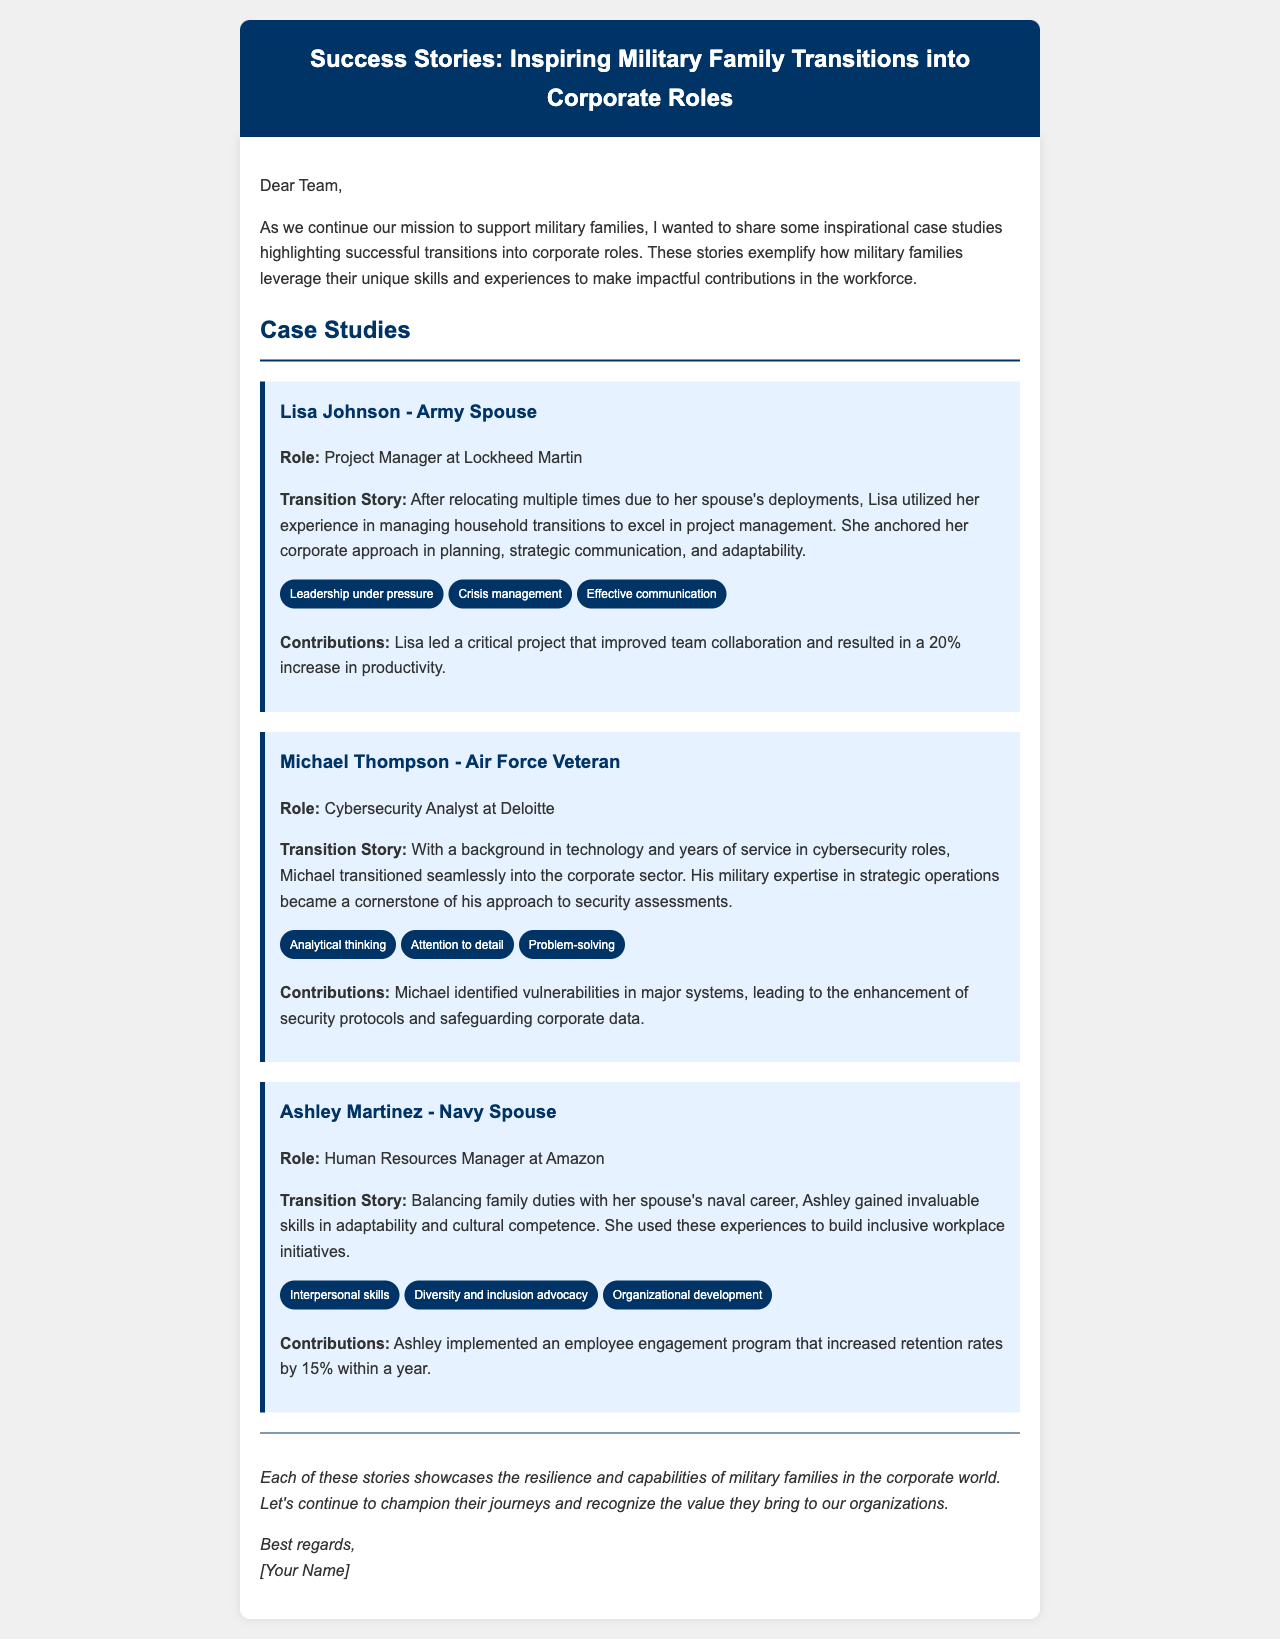What is Lisa Johnson's role? Lisa Johnson is a Project Manager at Lockheed Martin, which is mentioned under her name.
Answer: Project Manager at Lockheed Martin What is the main contribution of Michael Thompson? Michael Thompson identified vulnerabilities in major systems, leading to enhancements in security protocols.
Answer: Enhancements in security protocols Which military branch does Ashley Martinez's spouse belong to? Ashley Martinez is a Navy spouse, which indicates her spouse is part of the Navy.
Answer: Navy How much did Lisa Johnson's project increase productivity by? The increase in productivity from Lisa's project is specified as 20%.
Answer: 20% What skills does Ashley Martinez possess? Ashley Martinez's skills include interpersonal skills, diversity and inclusion advocacy, and organizational development, as listed in her case study.
Answer: Interpersonal skills, diversity and inclusion advocacy, organizational development What improvement was noted in employee retention due to Ashley's initiatives? It is noted that Ashley’s initiatives increased retention rates by 15% within a year.
Answer: 15% What aspect of his military experience helped Michael Thompson in his corporate role? Michael's experience in strategic operations during his military service played a key role in his approach to security assessments.
Answer: Strategic operations What is the key theme of the email? The key theme is to highlight inspirational success stories of military families transitioning into corporate roles.
Answer: Inspirational success stories How does the document categorize the featured examples? The document categorizes the features under case studies, each providing details on individual military families.
Answer: Case studies 